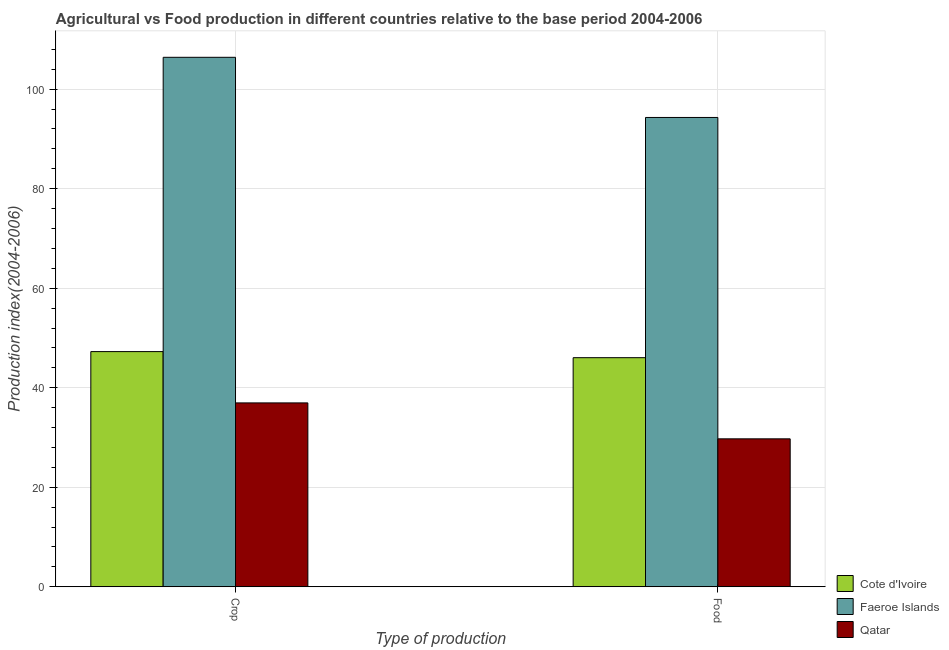How many groups of bars are there?
Make the answer very short. 2. Are the number of bars on each tick of the X-axis equal?
Provide a succinct answer. Yes. What is the label of the 1st group of bars from the left?
Provide a succinct answer. Crop. What is the crop production index in Faeroe Islands?
Provide a short and direct response. 106.41. Across all countries, what is the maximum food production index?
Provide a short and direct response. 94.32. Across all countries, what is the minimum crop production index?
Ensure brevity in your answer.  36.95. In which country was the food production index maximum?
Make the answer very short. Faeroe Islands. In which country was the crop production index minimum?
Make the answer very short. Qatar. What is the total food production index in the graph?
Your answer should be very brief. 170.09. What is the difference between the crop production index in Cote d'Ivoire and that in Qatar?
Your answer should be compact. 10.31. What is the difference between the crop production index in Faeroe Islands and the food production index in Cote d'Ivoire?
Keep it short and to the point. 60.37. What is the average food production index per country?
Ensure brevity in your answer.  56.7. What is the difference between the crop production index and food production index in Faeroe Islands?
Give a very brief answer. 12.09. What is the ratio of the crop production index in Cote d'Ivoire to that in Faeroe Islands?
Your response must be concise. 0.44. Is the food production index in Qatar less than that in Cote d'Ivoire?
Give a very brief answer. Yes. What does the 2nd bar from the left in Food represents?
Offer a terse response. Faeroe Islands. What does the 2nd bar from the right in Food represents?
Offer a very short reply. Faeroe Islands. Are all the bars in the graph horizontal?
Offer a terse response. No. What is the difference between two consecutive major ticks on the Y-axis?
Your response must be concise. 20. Does the graph contain any zero values?
Offer a terse response. No. How many legend labels are there?
Offer a very short reply. 3. What is the title of the graph?
Make the answer very short. Agricultural vs Food production in different countries relative to the base period 2004-2006. Does "Belize" appear as one of the legend labels in the graph?
Give a very brief answer. No. What is the label or title of the X-axis?
Give a very brief answer. Type of production. What is the label or title of the Y-axis?
Keep it short and to the point. Production index(2004-2006). What is the Production index(2004-2006) in Cote d'Ivoire in Crop?
Your response must be concise. 47.26. What is the Production index(2004-2006) in Faeroe Islands in Crop?
Offer a very short reply. 106.41. What is the Production index(2004-2006) of Qatar in Crop?
Offer a terse response. 36.95. What is the Production index(2004-2006) of Cote d'Ivoire in Food?
Offer a terse response. 46.04. What is the Production index(2004-2006) in Faeroe Islands in Food?
Your answer should be very brief. 94.32. What is the Production index(2004-2006) of Qatar in Food?
Ensure brevity in your answer.  29.73. Across all Type of production, what is the maximum Production index(2004-2006) of Cote d'Ivoire?
Keep it short and to the point. 47.26. Across all Type of production, what is the maximum Production index(2004-2006) of Faeroe Islands?
Provide a succinct answer. 106.41. Across all Type of production, what is the maximum Production index(2004-2006) in Qatar?
Provide a succinct answer. 36.95. Across all Type of production, what is the minimum Production index(2004-2006) in Cote d'Ivoire?
Give a very brief answer. 46.04. Across all Type of production, what is the minimum Production index(2004-2006) in Faeroe Islands?
Provide a short and direct response. 94.32. Across all Type of production, what is the minimum Production index(2004-2006) in Qatar?
Keep it short and to the point. 29.73. What is the total Production index(2004-2006) in Cote d'Ivoire in the graph?
Your response must be concise. 93.3. What is the total Production index(2004-2006) in Faeroe Islands in the graph?
Make the answer very short. 200.73. What is the total Production index(2004-2006) in Qatar in the graph?
Give a very brief answer. 66.68. What is the difference between the Production index(2004-2006) of Cote d'Ivoire in Crop and that in Food?
Offer a very short reply. 1.22. What is the difference between the Production index(2004-2006) of Faeroe Islands in Crop and that in Food?
Offer a very short reply. 12.09. What is the difference between the Production index(2004-2006) in Qatar in Crop and that in Food?
Give a very brief answer. 7.22. What is the difference between the Production index(2004-2006) of Cote d'Ivoire in Crop and the Production index(2004-2006) of Faeroe Islands in Food?
Offer a terse response. -47.06. What is the difference between the Production index(2004-2006) in Cote d'Ivoire in Crop and the Production index(2004-2006) in Qatar in Food?
Provide a succinct answer. 17.53. What is the difference between the Production index(2004-2006) of Faeroe Islands in Crop and the Production index(2004-2006) of Qatar in Food?
Your answer should be compact. 76.68. What is the average Production index(2004-2006) in Cote d'Ivoire per Type of production?
Keep it short and to the point. 46.65. What is the average Production index(2004-2006) of Faeroe Islands per Type of production?
Offer a very short reply. 100.36. What is the average Production index(2004-2006) in Qatar per Type of production?
Provide a short and direct response. 33.34. What is the difference between the Production index(2004-2006) in Cote d'Ivoire and Production index(2004-2006) in Faeroe Islands in Crop?
Keep it short and to the point. -59.15. What is the difference between the Production index(2004-2006) in Cote d'Ivoire and Production index(2004-2006) in Qatar in Crop?
Provide a succinct answer. 10.31. What is the difference between the Production index(2004-2006) of Faeroe Islands and Production index(2004-2006) of Qatar in Crop?
Keep it short and to the point. 69.46. What is the difference between the Production index(2004-2006) in Cote d'Ivoire and Production index(2004-2006) in Faeroe Islands in Food?
Your response must be concise. -48.28. What is the difference between the Production index(2004-2006) in Cote d'Ivoire and Production index(2004-2006) in Qatar in Food?
Offer a terse response. 16.31. What is the difference between the Production index(2004-2006) of Faeroe Islands and Production index(2004-2006) of Qatar in Food?
Your response must be concise. 64.59. What is the ratio of the Production index(2004-2006) in Cote d'Ivoire in Crop to that in Food?
Your answer should be very brief. 1.03. What is the ratio of the Production index(2004-2006) of Faeroe Islands in Crop to that in Food?
Offer a terse response. 1.13. What is the ratio of the Production index(2004-2006) of Qatar in Crop to that in Food?
Ensure brevity in your answer.  1.24. What is the difference between the highest and the second highest Production index(2004-2006) of Cote d'Ivoire?
Your response must be concise. 1.22. What is the difference between the highest and the second highest Production index(2004-2006) of Faeroe Islands?
Your answer should be compact. 12.09. What is the difference between the highest and the second highest Production index(2004-2006) of Qatar?
Your answer should be very brief. 7.22. What is the difference between the highest and the lowest Production index(2004-2006) in Cote d'Ivoire?
Provide a short and direct response. 1.22. What is the difference between the highest and the lowest Production index(2004-2006) of Faeroe Islands?
Your response must be concise. 12.09. What is the difference between the highest and the lowest Production index(2004-2006) in Qatar?
Offer a terse response. 7.22. 